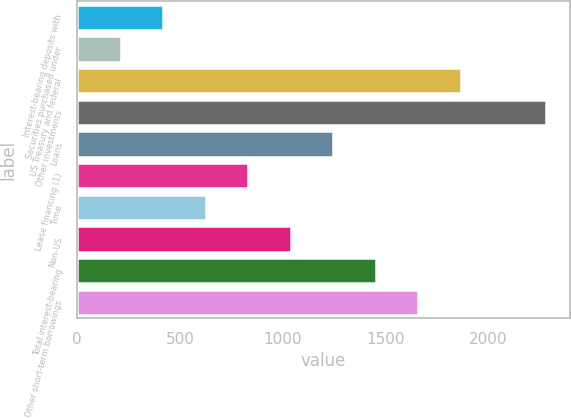Convert chart. <chart><loc_0><loc_0><loc_500><loc_500><bar_chart><fcel>Interest-bearing deposits with<fcel>Securities purchased under<fcel>US Treasury and federal<fcel>Other investments<fcel>Loans<fcel>Lease financing (1)<fcel>Time<fcel>Non-US<fcel>Total interest-bearing<fcel>Other short-term borrowings<nl><fcel>419<fcel>212<fcel>1868<fcel>2282<fcel>1247<fcel>833<fcel>626<fcel>1040<fcel>1454<fcel>1661<nl></chart> 